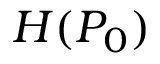<formula> <loc_0><loc_0><loc_500><loc_500>H ( P _ { 0 } )</formula> 